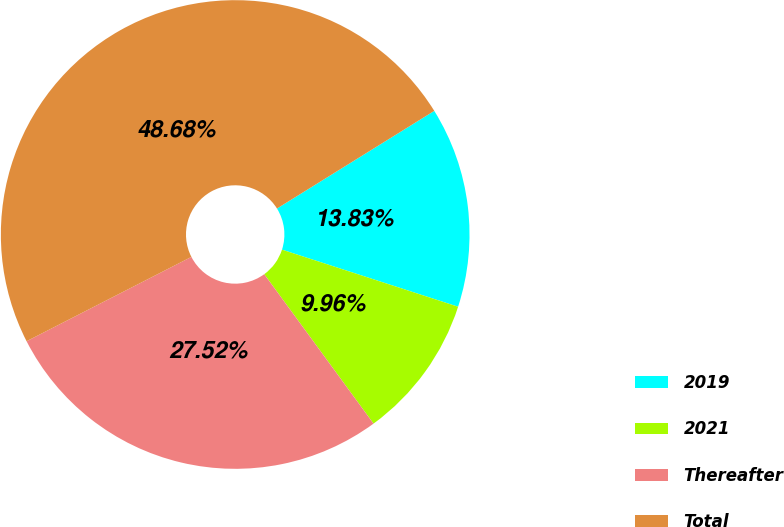Convert chart to OTSL. <chart><loc_0><loc_0><loc_500><loc_500><pie_chart><fcel>2019<fcel>2021<fcel>Thereafter<fcel>Total<nl><fcel>13.83%<fcel>9.96%<fcel>27.52%<fcel>48.68%<nl></chart> 